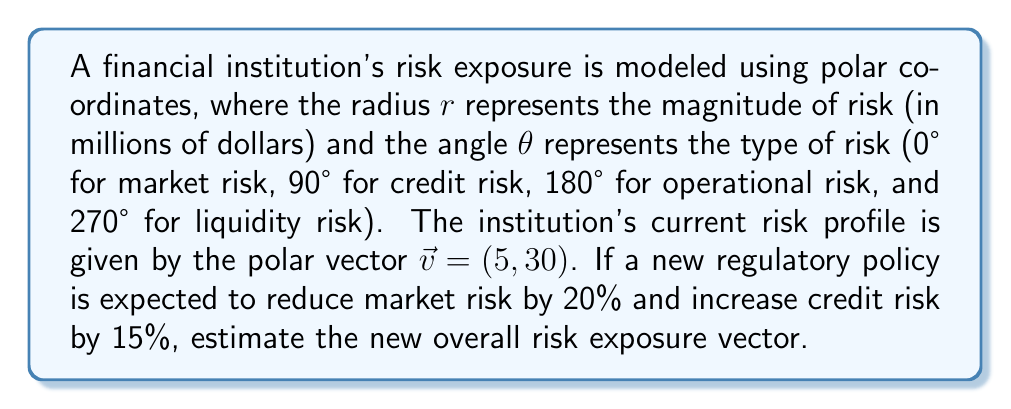Provide a solution to this math problem. To solve this problem, we'll follow these steps:

1) First, let's break down the initial risk vector into its rectangular components:
   $x = r \cos(\theta) = 5 \cos(30°) = 5 \cdot \frac{\sqrt{3}}{2} = 2.5\sqrt{3}$
   $y = r \sin(\theta) = 5 \sin(30°) = 5 \cdot \frac{1}{2} = 2.5$

2) The x-component represents market risk, and the y-component represents credit risk.

3) Apply the changes:
   New market risk: $2.5\sqrt{3} \cdot 0.8 = 2\sqrt{3}$ (20% reduction)
   New credit risk: $2.5 \cdot 1.15 = 2.875$ (15% increase)

4) Now we have a new rectangular vector $(2\sqrt{3}, 2.875)$

5) To convert back to polar coordinates, we use:
   $r = \sqrt{x^2 + y^2} = \sqrt{(2\sqrt{3})^2 + 2.875^2} = \sqrt{12 + 8.265625} = \sqrt{20.265625} \approx 4.50$

6) For the angle:
   $\theta = \tan^{-1}(\frac{y}{x}) = \tan^{-1}(\frac{2.875}{2\sqrt{3}}) \approx 40.60°$

Therefore, the new risk exposure vector in polar coordinates is approximately $(4.50, 40.60°)$.
Answer: $$(4.50, 40.60°)$$ 